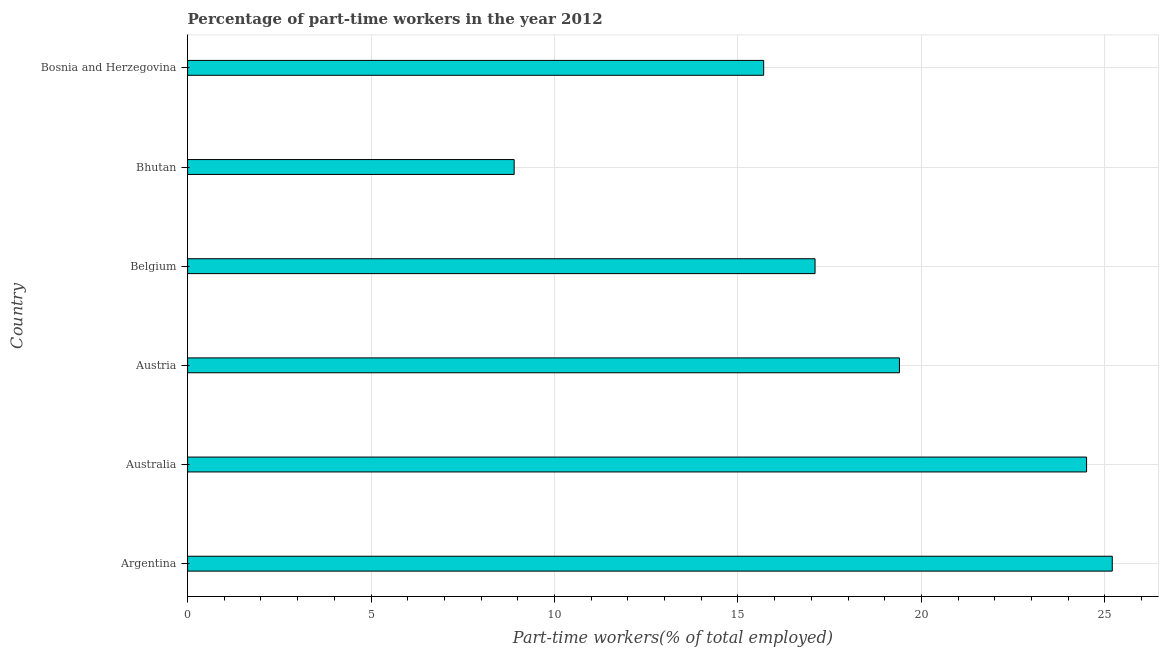Does the graph contain any zero values?
Keep it short and to the point. No. What is the title of the graph?
Give a very brief answer. Percentage of part-time workers in the year 2012. What is the label or title of the X-axis?
Provide a short and direct response. Part-time workers(% of total employed). What is the label or title of the Y-axis?
Keep it short and to the point. Country. What is the percentage of part-time workers in Austria?
Give a very brief answer. 19.4. Across all countries, what is the maximum percentage of part-time workers?
Offer a terse response. 25.2. Across all countries, what is the minimum percentage of part-time workers?
Make the answer very short. 8.9. In which country was the percentage of part-time workers maximum?
Your response must be concise. Argentina. In which country was the percentage of part-time workers minimum?
Offer a very short reply. Bhutan. What is the sum of the percentage of part-time workers?
Your response must be concise. 110.8. What is the average percentage of part-time workers per country?
Your response must be concise. 18.47. What is the median percentage of part-time workers?
Keep it short and to the point. 18.25. In how many countries, is the percentage of part-time workers greater than 1 %?
Keep it short and to the point. 6. What is the ratio of the percentage of part-time workers in Belgium to that in Bhutan?
Offer a terse response. 1.92. Is the percentage of part-time workers in Austria less than that in Bosnia and Herzegovina?
Provide a succinct answer. No. What is the difference between the highest and the second highest percentage of part-time workers?
Ensure brevity in your answer.  0.7. Is the sum of the percentage of part-time workers in Australia and Austria greater than the maximum percentage of part-time workers across all countries?
Your answer should be very brief. Yes. What is the difference between the highest and the lowest percentage of part-time workers?
Offer a terse response. 16.3. What is the Part-time workers(% of total employed) in Argentina?
Provide a succinct answer. 25.2. What is the Part-time workers(% of total employed) in Austria?
Your response must be concise. 19.4. What is the Part-time workers(% of total employed) in Belgium?
Offer a very short reply. 17.1. What is the Part-time workers(% of total employed) of Bhutan?
Your response must be concise. 8.9. What is the Part-time workers(% of total employed) of Bosnia and Herzegovina?
Keep it short and to the point. 15.7. What is the difference between the Part-time workers(% of total employed) in Argentina and Australia?
Provide a short and direct response. 0.7. What is the difference between the Part-time workers(% of total employed) in Argentina and Bhutan?
Provide a succinct answer. 16.3. What is the difference between the Part-time workers(% of total employed) in Australia and Belgium?
Provide a short and direct response. 7.4. What is the difference between the Part-time workers(% of total employed) in Australia and Bhutan?
Make the answer very short. 15.6. What is the difference between the Part-time workers(% of total employed) in Australia and Bosnia and Herzegovina?
Provide a short and direct response. 8.8. What is the difference between the Part-time workers(% of total employed) in Austria and Belgium?
Provide a succinct answer. 2.3. What is the difference between the Part-time workers(% of total employed) in Austria and Bhutan?
Make the answer very short. 10.5. What is the difference between the Part-time workers(% of total employed) in Belgium and Bhutan?
Provide a short and direct response. 8.2. What is the difference between the Part-time workers(% of total employed) in Belgium and Bosnia and Herzegovina?
Ensure brevity in your answer.  1.4. What is the ratio of the Part-time workers(% of total employed) in Argentina to that in Austria?
Ensure brevity in your answer.  1.3. What is the ratio of the Part-time workers(% of total employed) in Argentina to that in Belgium?
Keep it short and to the point. 1.47. What is the ratio of the Part-time workers(% of total employed) in Argentina to that in Bhutan?
Make the answer very short. 2.83. What is the ratio of the Part-time workers(% of total employed) in Argentina to that in Bosnia and Herzegovina?
Offer a terse response. 1.6. What is the ratio of the Part-time workers(% of total employed) in Australia to that in Austria?
Give a very brief answer. 1.26. What is the ratio of the Part-time workers(% of total employed) in Australia to that in Belgium?
Your response must be concise. 1.43. What is the ratio of the Part-time workers(% of total employed) in Australia to that in Bhutan?
Your response must be concise. 2.75. What is the ratio of the Part-time workers(% of total employed) in Australia to that in Bosnia and Herzegovina?
Your answer should be very brief. 1.56. What is the ratio of the Part-time workers(% of total employed) in Austria to that in Belgium?
Make the answer very short. 1.14. What is the ratio of the Part-time workers(% of total employed) in Austria to that in Bhutan?
Keep it short and to the point. 2.18. What is the ratio of the Part-time workers(% of total employed) in Austria to that in Bosnia and Herzegovina?
Your response must be concise. 1.24. What is the ratio of the Part-time workers(% of total employed) in Belgium to that in Bhutan?
Provide a succinct answer. 1.92. What is the ratio of the Part-time workers(% of total employed) in Belgium to that in Bosnia and Herzegovina?
Make the answer very short. 1.09. What is the ratio of the Part-time workers(% of total employed) in Bhutan to that in Bosnia and Herzegovina?
Offer a very short reply. 0.57. 